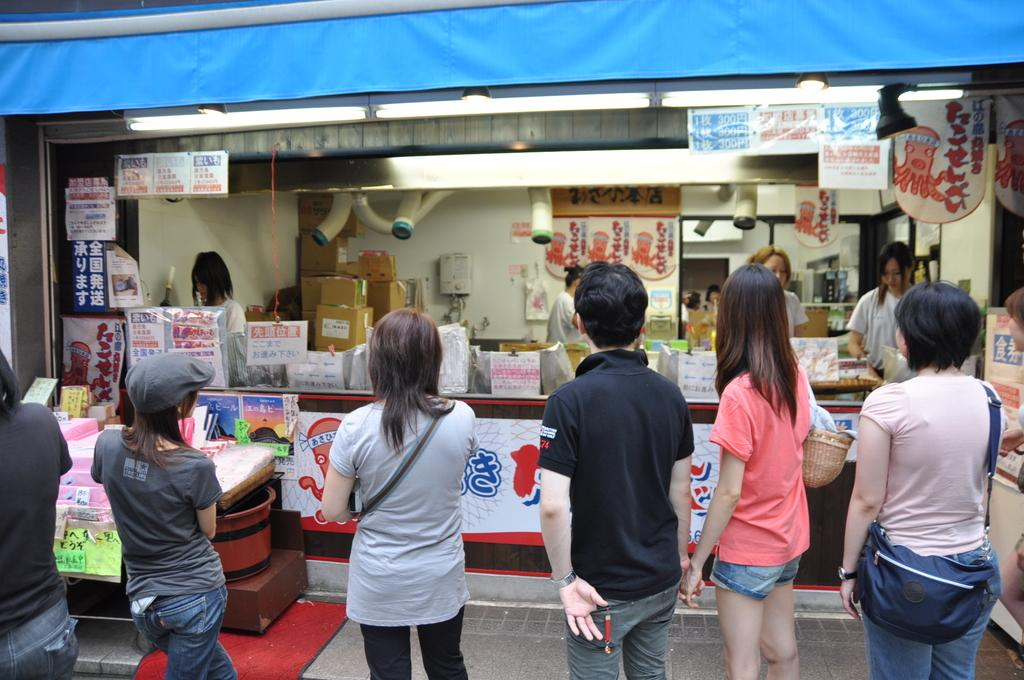What is happening on the ground in the image? There are people on the ground in the image. What type of establishment can be seen in the image? There is a shop in the image. What items are visible in the image that are packaged or stored? There are boxes in the image. What type of promotional materials are present in the image? There are posters in the image. Can you describe any other objects present in the image? There are other objects present in the image, but their specific nature is not mentioned in the provided facts. What type of lunch is being served to the spy in the image? There is no mention of a spy or lunch in the image, so this question cannot be answered definitively. 